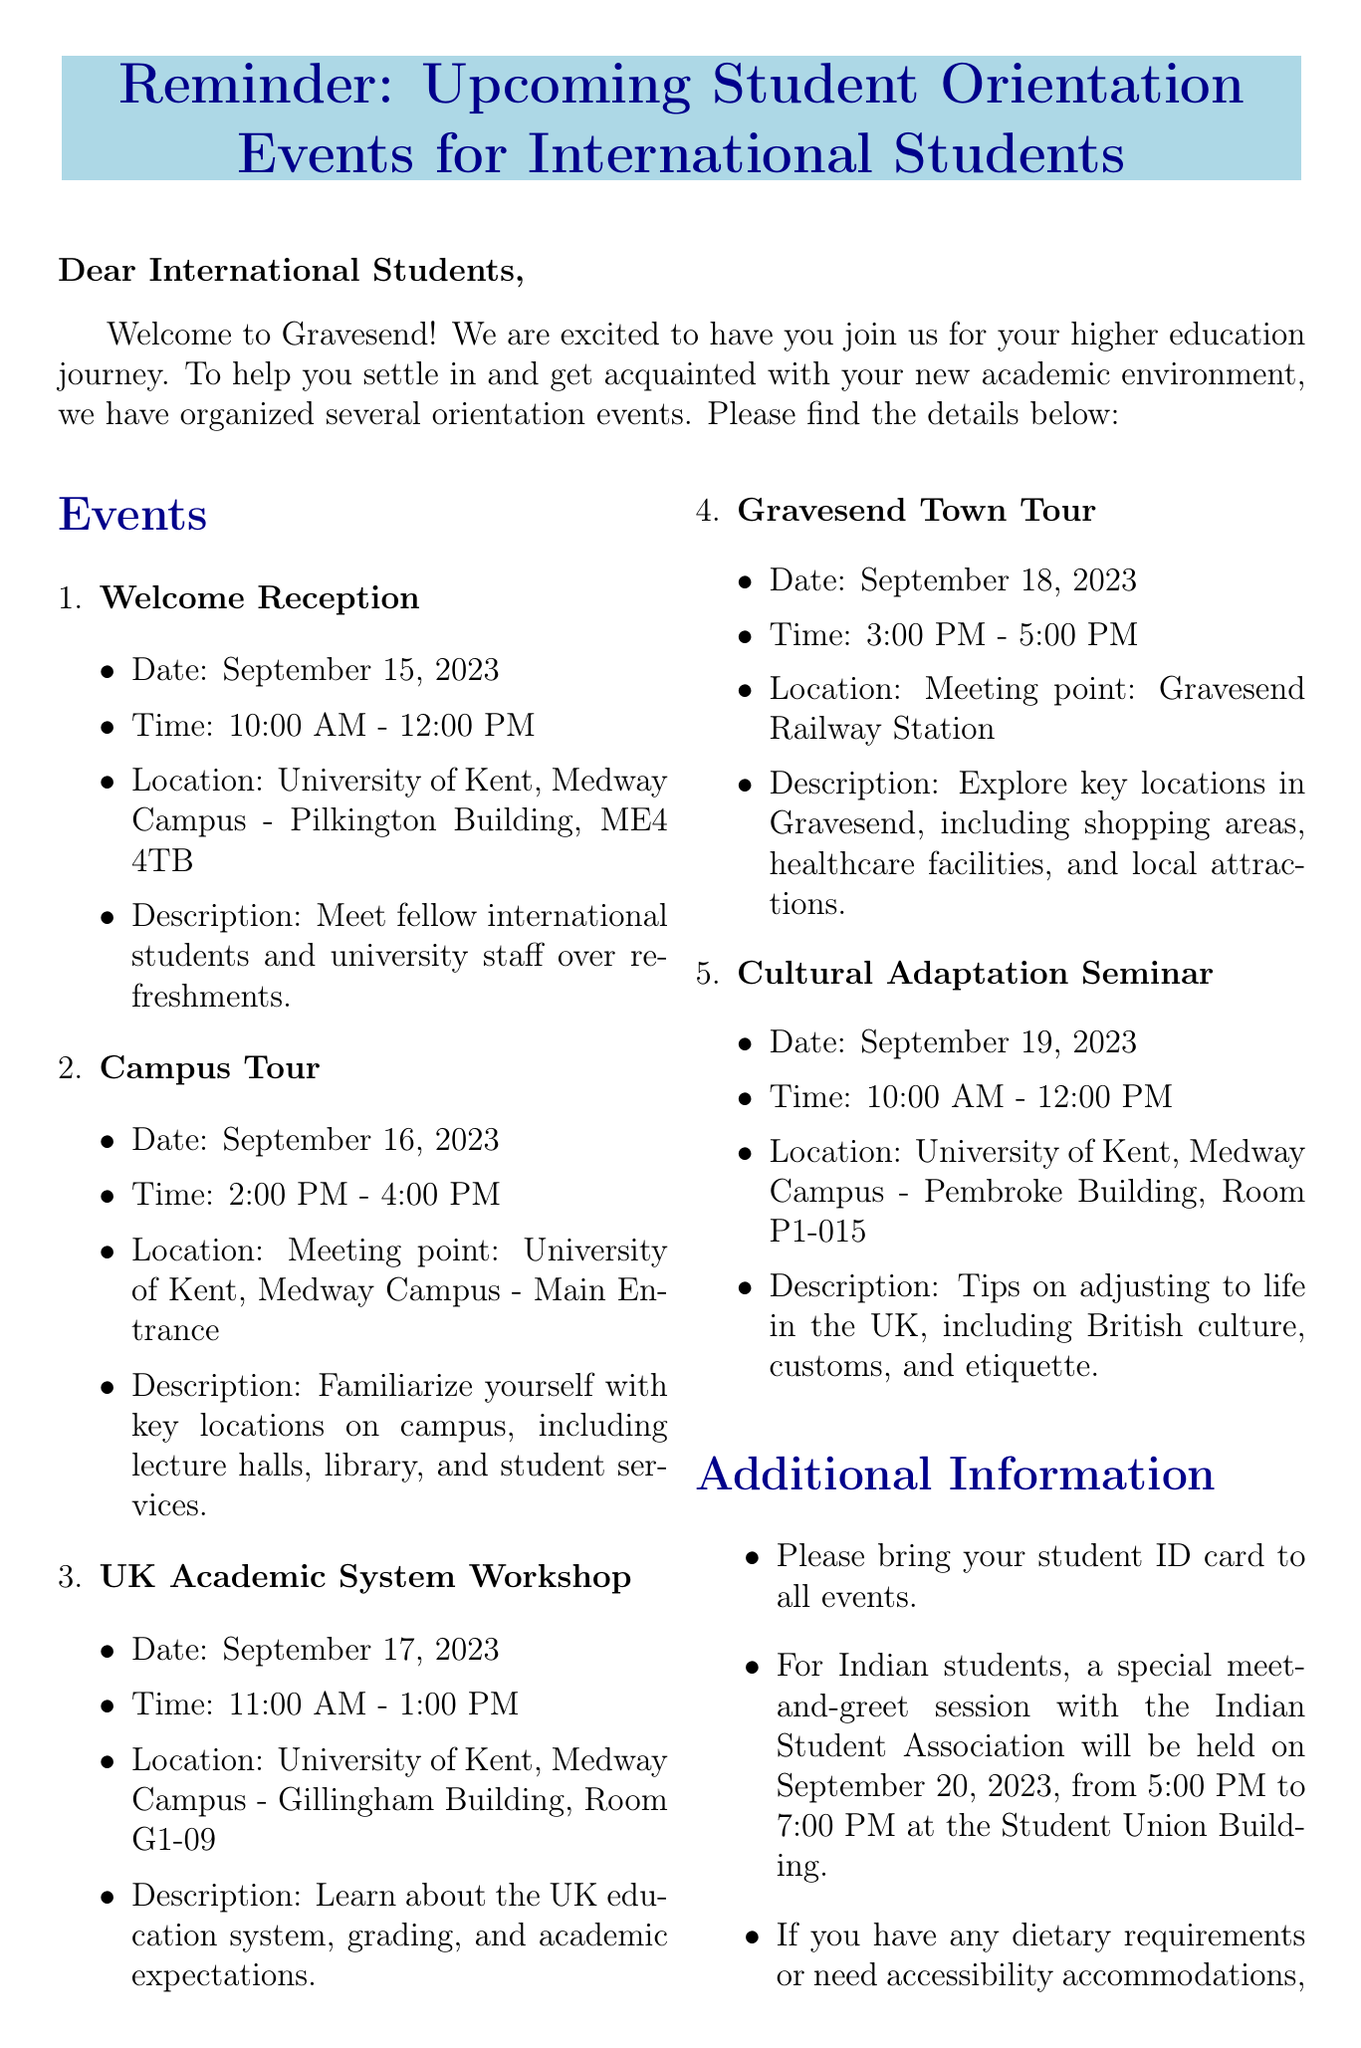What is the date of the Welcome Reception? The Welcome Reception is scheduled for September 15, 2023, as stated in the events section.
Answer: September 15, 2023 What time does the Campus Tour start? The Campus Tour starts at 2:00 PM, as mentioned in the event details.
Answer: 2:00 PM Where is the Gravesend Town Tour meeting point? The meeting point for the Gravesend Town Tour is Gravesend Railway Station, as indicated in the location section.
Answer: Gravesend Railway Station How long is the Cultural Adaptation Seminar? The seminar lasts for 2 hours, from 10:00 AM to 12:00 PM, providing its duration.
Answer: 2 hours Who is the contact person for the orientation events? Dr. Emily Thompson is listed as the contact person in the document.
Answer: Dr. Emily Thompson On what date is the special session for Indian students? The special meet-and-greet session is on September 20, 2023, as specified under additional information.
Answer: September 20, 2023 What do students need to bring to all events? Students are required to bring their student ID card to all events as mentioned in the additional information section.
Answer: Student ID card What is the email address to inform about dietary requirements? The email address provided for dietary requirements is iso@kent.ac.uk, as stated in the document.
Answer: iso@kent.ac.uk What type of events are included in the orientation? The orientation includes events like receptions, workshops, and tours, listed under the events section.
Answer: Receptions, workshops, and tours 